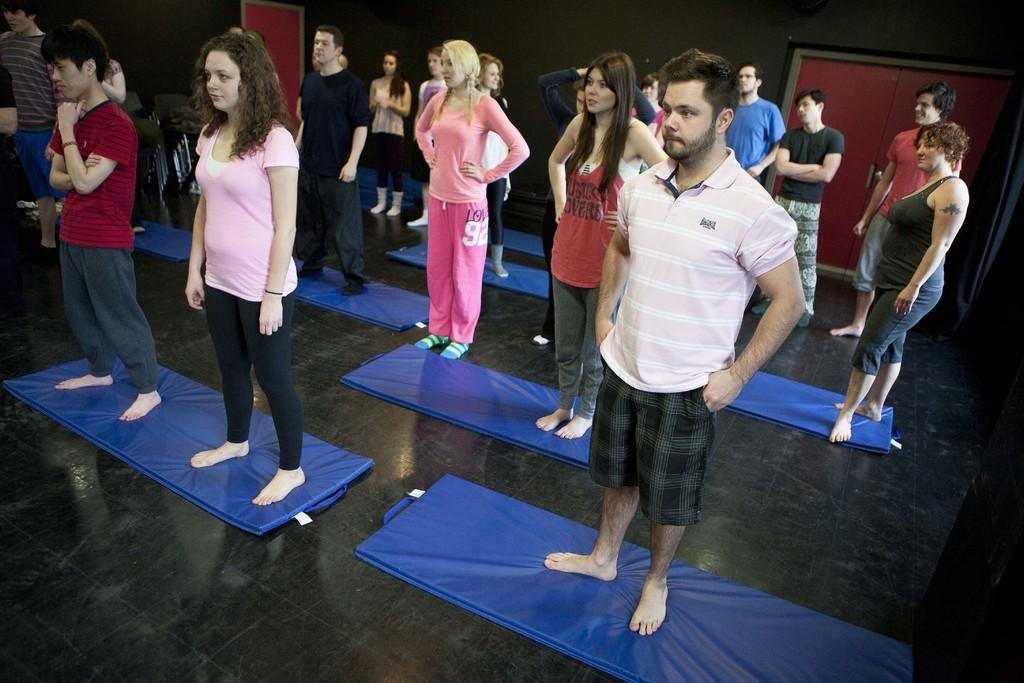How many people are in the image? There is a group of people in the image. What are the people standing on? The people are standing on mats. Where are the mats located? The mats are on the floor. What can be seen in the background of the image? There is a door with a door handle in the background of the image. What type of zephyr can be seen flowing through the image? There is no zephyr present in the image; it is a group of people standing on mats with a door in the background. 